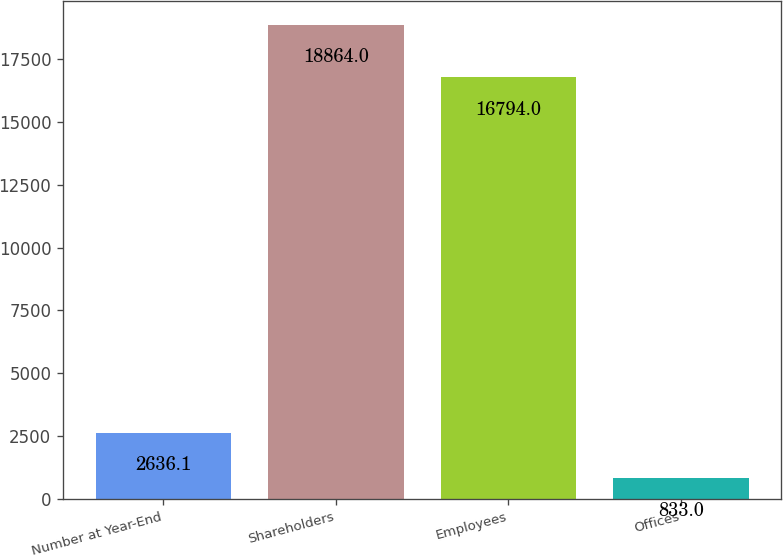Convert chart. <chart><loc_0><loc_0><loc_500><loc_500><bar_chart><fcel>Number at Year-End<fcel>Shareholders<fcel>Employees<fcel>Offices<nl><fcel>2636.1<fcel>18864<fcel>16794<fcel>833<nl></chart> 